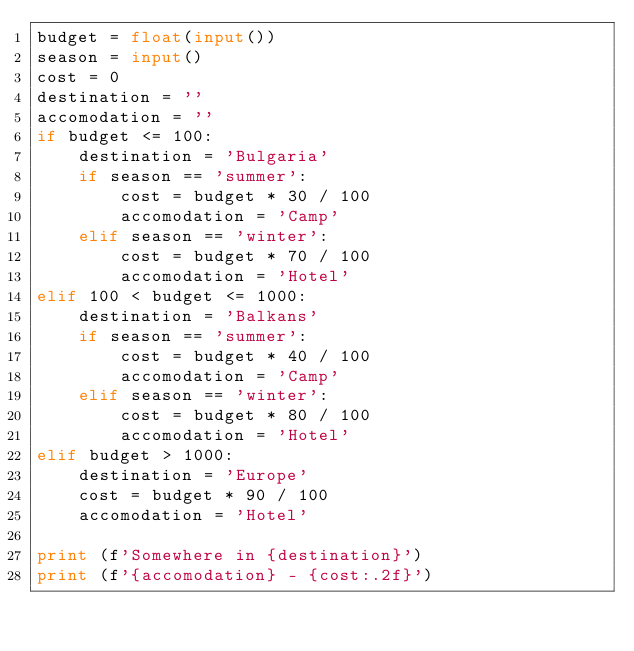Convert code to text. <code><loc_0><loc_0><loc_500><loc_500><_Python_>budget = float(input())
season = input()
cost = 0
destination = ''
accomodation = ''
if budget <= 100:
    destination = 'Bulgaria'
    if season == 'summer':
        cost = budget * 30 / 100
        accomodation = 'Camp'
    elif season == 'winter':
        cost = budget * 70 / 100
        accomodation = 'Hotel'
elif 100 < budget <= 1000:
    destination = 'Balkans'
    if season == 'summer':
        cost = budget * 40 / 100
        accomodation = 'Camp'
    elif season == 'winter':
        cost = budget * 80 / 100
        accomodation = 'Hotel'
elif budget > 1000:
    destination = 'Europe'
    cost = budget * 90 / 100
    accomodation = 'Hotel'

print (f'Somewhere in {destination}')
print (f'{accomodation} - {cost:.2f}')
</code> 